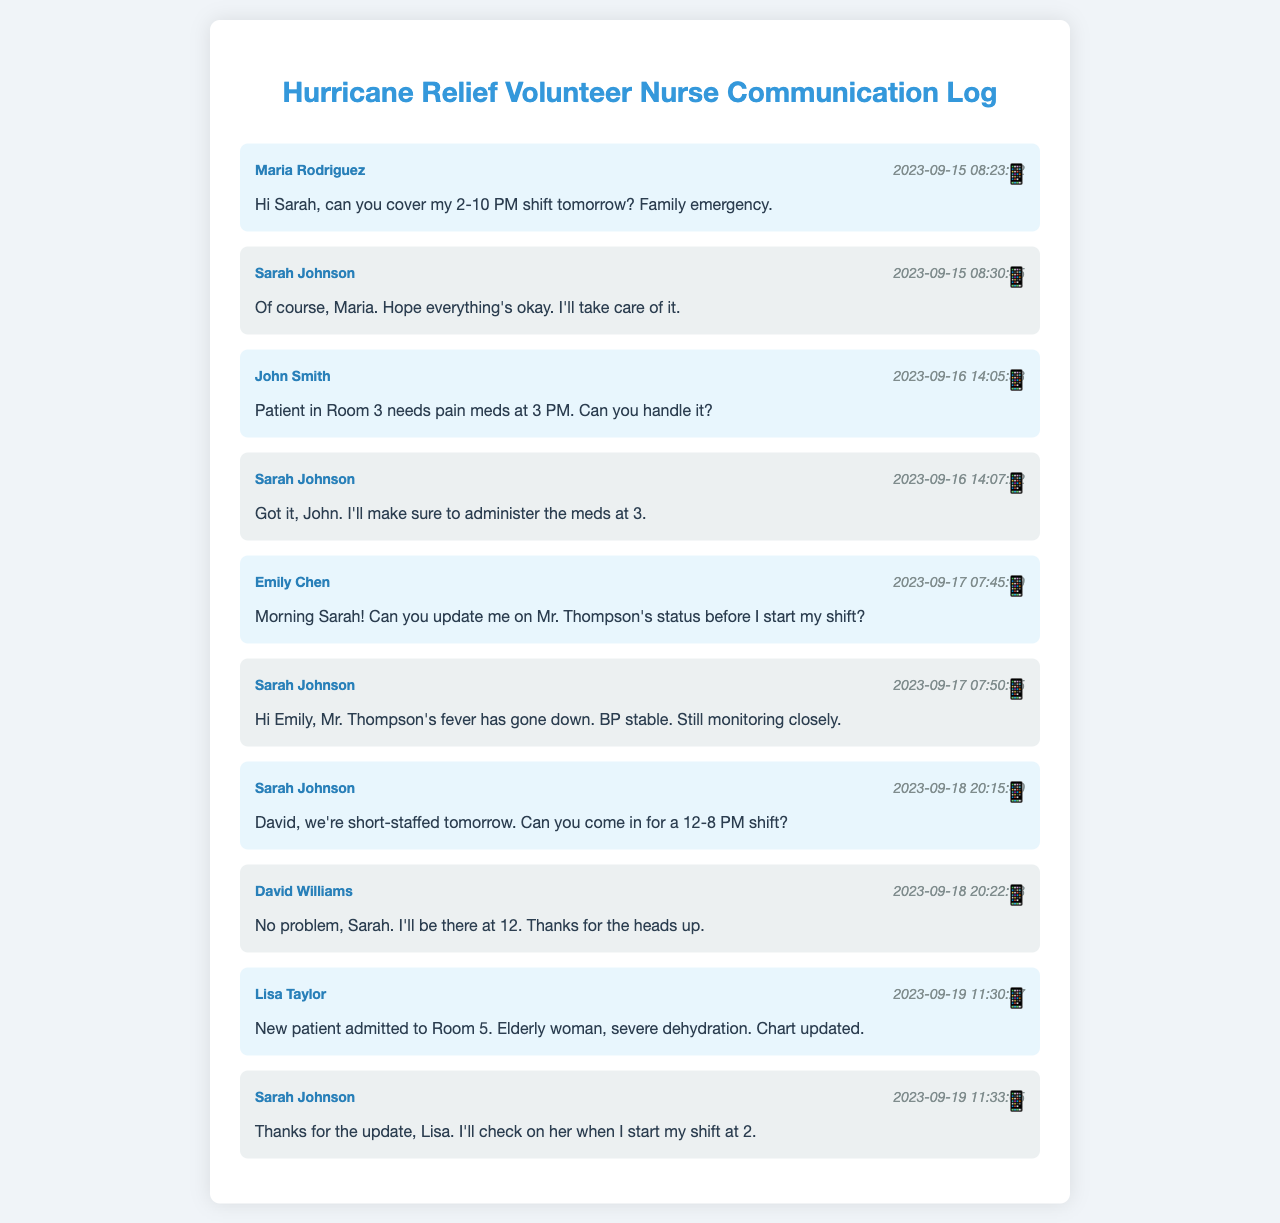what is the name of the nurse requesting coverage for their shift? Maria Rodriguez is the one asking for someone to cover her shift due to a family emergency.
Answer: Maria Rodriguez when was the message about Mr. Thompson's status sent? The message providing an update on Mr. Thompson's status was sent on September 17, 2023, at 07:50:55.
Answer: 2023-09-17 07:50:55 who offered to take care of the pain medication for a patient? Sarah Johnson responded to John's request and confirmed she would administer the pain medication.
Answer: Sarah Johnson how long was Sarah's shift on September 19? Sarah mentioned that she would start her shift at 2 PM, but the end time is not explicitly stated. However, based on typical nurse shifts, it could be inferred commonly to end around 8 PM if there’s no clear indication otherwise.
Answer: 6 hours what was the main concern in Lisa's message? Lisa's message highlighted the admission of a new patient in Room 5 with severe dehydration.
Answer: severe dehydration which day did David agree to work the extra shift? David confirmed he would work the extra shift on September 19, 2023.
Answer: September 19 what time did John send the message about the patient needing pain meds? John sent the message at 14:05:33 on September 16, 2023.
Answer: 14:05:33 how did Sarah respond to Maria’s request? Sarah agreed to cover Maria's shift and expressed her concern for her situation.
Answer: I'll take care of it 